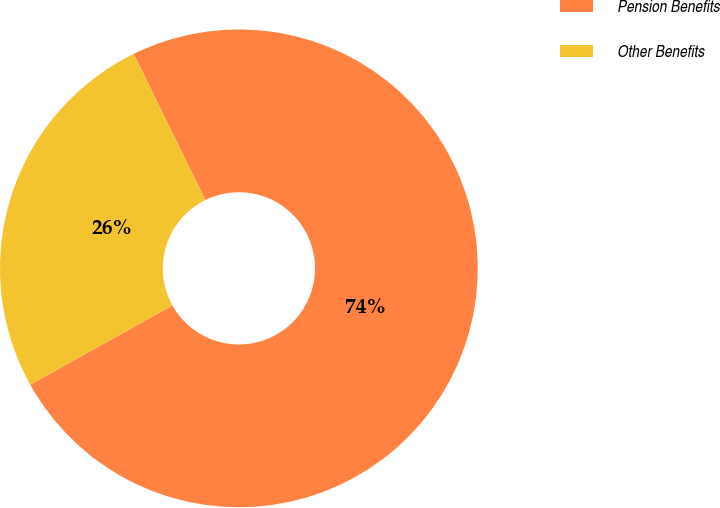<chart> <loc_0><loc_0><loc_500><loc_500><pie_chart><fcel>Pension Benefits<fcel>Other Benefits<nl><fcel>74.17%<fcel>25.83%<nl></chart> 